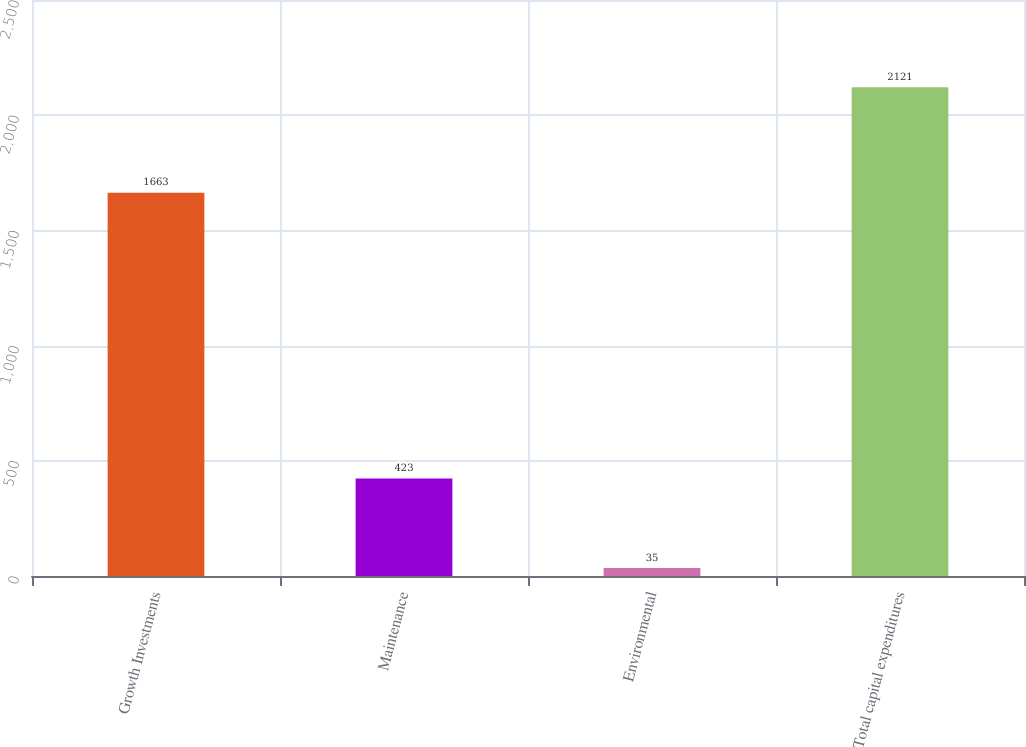Convert chart to OTSL. <chart><loc_0><loc_0><loc_500><loc_500><bar_chart><fcel>Growth Investments<fcel>Maintenance<fcel>Environmental<fcel>Total capital expenditures<nl><fcel>1663<fcel>423<fcel>35<fcel>2121<nl></chart> 